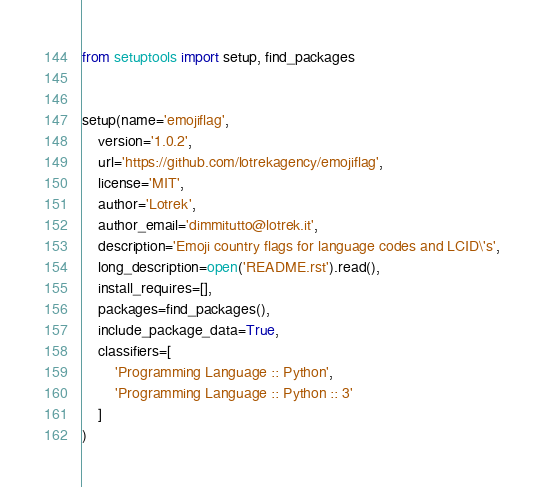Convert code to text. <code><loc_0><loc_0><loc_500><loc_500><_Python_>from setuptools import setup, find_packages


setup(name='emojiflag',
	version='1.0.2',
	url='https://github.com/lotrekagency/emojiflag',
	license='MIT',
	author='Lotrek',
	author_email='dimmitutto@lotrek.it',
	description='Emoji country flags for language codes and LCID\'s',
	long_description=open('README.rst').read(),
	install_requires=[],
	packages=find_packages(),
    include_package_data=True,
    classifiers=[
        'Programming Language :: Python',
        'Programming Language :: Python :: 3'
    ]
)
</code> 